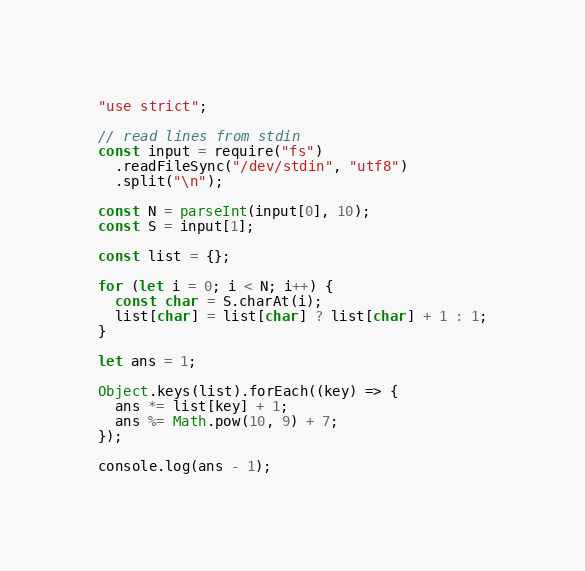<code> <loc_0><loc_0><loc_500><loc_500><_JavaScript_>"use strict";

// read lines from stdin
const input = require("fs")
  .readFileSync("/dev/stdin", "utf8")
  .split("\n");

const N = parseInt(input[0], 10);
const S = input[1];

const list = {};

for (let i = 0; i < N; i++) {
  const char = S.charAt(i);
  list[char] = list[char] ? list[char] + 1 : 1;
}

let ans = 1;

Object.keys(list).forEach((key) => {
  ans *= list[key] + 1;
  ans %= Math.pow(10, 9) + 7;
});

console.log(ans - 1);
</code> 